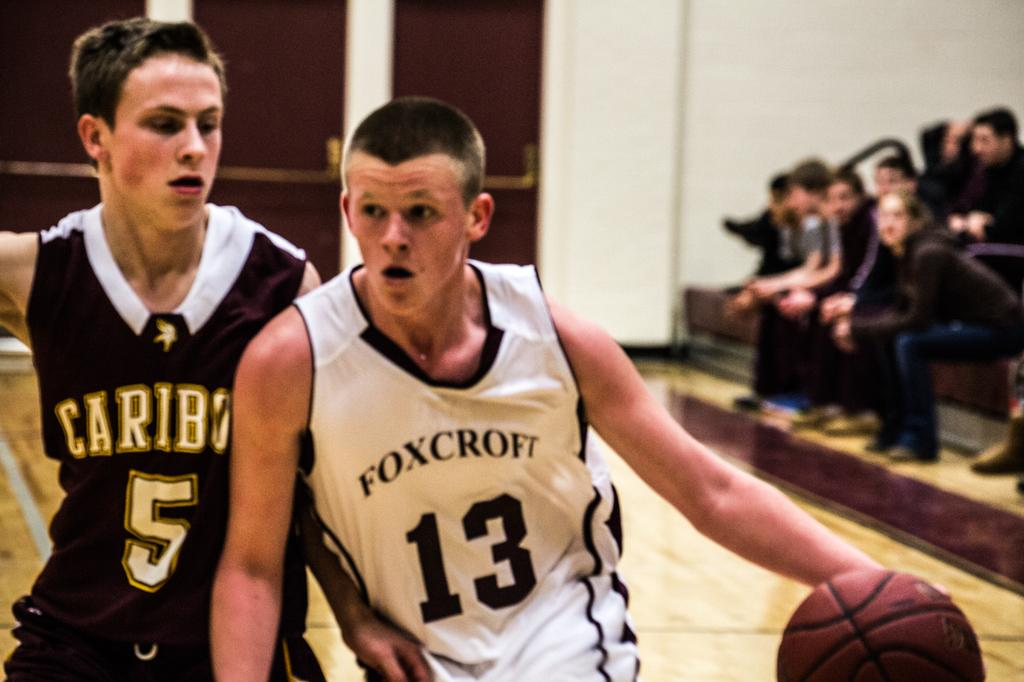<image>
Share a concise interpretation of the image provided. A basketball game and the player with the ball has a jersey on that says Foxcroft 13. 